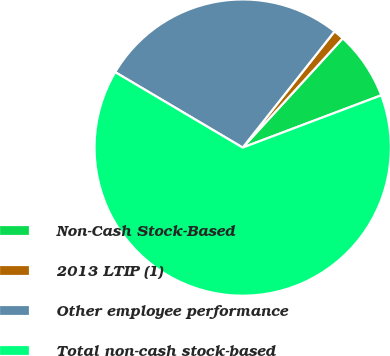Convert chart to OTSL. <chart><loc_0><loc_0><loc_500><loc_500><pie_chart><fcel>Non-Cash Stock-Based<fcel>2013 LTIP (1)<fcel>Other employee performance<fcel>Total non-cash stock-based<nl><fcel>7.46%<fcel>1.15%<fcel>27.14%<fcel>64.24%<nl></chart> 